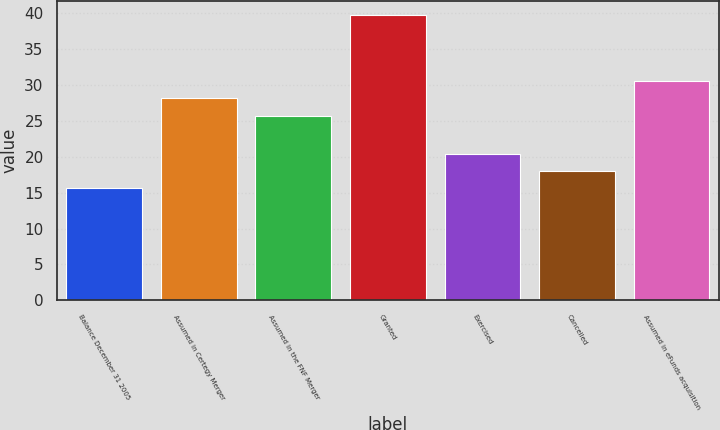Convert chart to OTSL. <chart><loc_0><loc_0><loc_500><loc_500><bar_chart><fcel>Balance December 31 2005<fcel>Assumed in Certegy Merger<fcel>Assumed in the FNF Merger<fcel>Granted<fcel>Exercised<fcel>Cancelled<fcel>Assumed in eFunds acquisition<nl><fcel>15.63<fcel>28.13<fcel>25.72<fcel>39.75<fcel>20.45<fcel>18.04<fcel>30.54<nl></chart> 